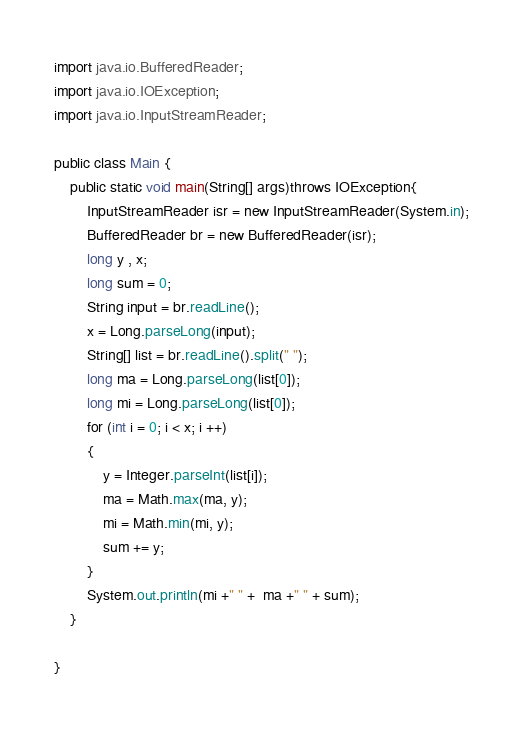<code> <loc_0><loc_0><loc_500><loc_500><_Java_>import java.io.BufferedReader;
import java.io.IOException;
import java.io.InputStreamReader;

public class Main {
	public static void main(String[] args)throws IOException{
		InputStreamReader isr = new InputStreamReader(System.in);
        BufferedReader br = new BufferedReader(isr);
        long y , x;
        long sum = 0;
        String input = br.readLine();
        x = Long.parseLong(input);
        String[] list = br.readLine().split(" ");
        long ma = Long.parseLong(list[0]);
        long mi = Long.parseLong(list[0]);
        for (int i = 0; i < x; i ++)
        {
        	y = Integer.parseInt(list[i]);
        	ma = Math.max(ma, y);
        	mi = Math.min(mi, y);
        	sum += y;
        }	
        System.out.println(mi +" " +  ma +" " + sum);
	}

}</code> 